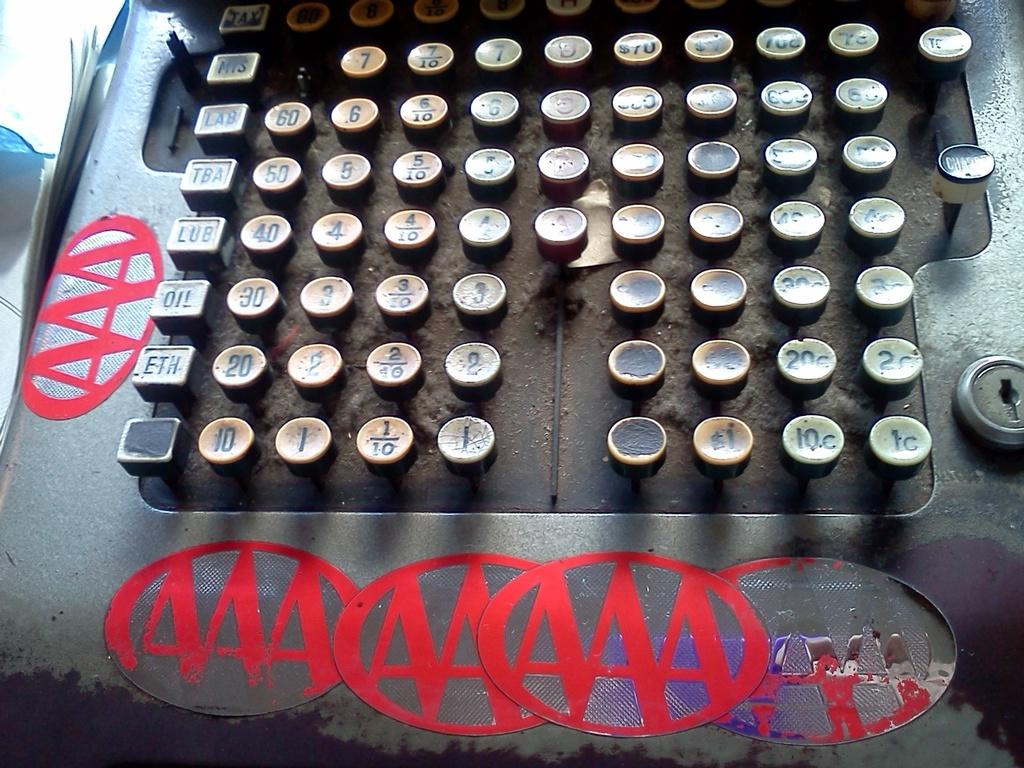<image>
Write a terse but informative summary of the picture. a typewriter with a lot of A's on it 